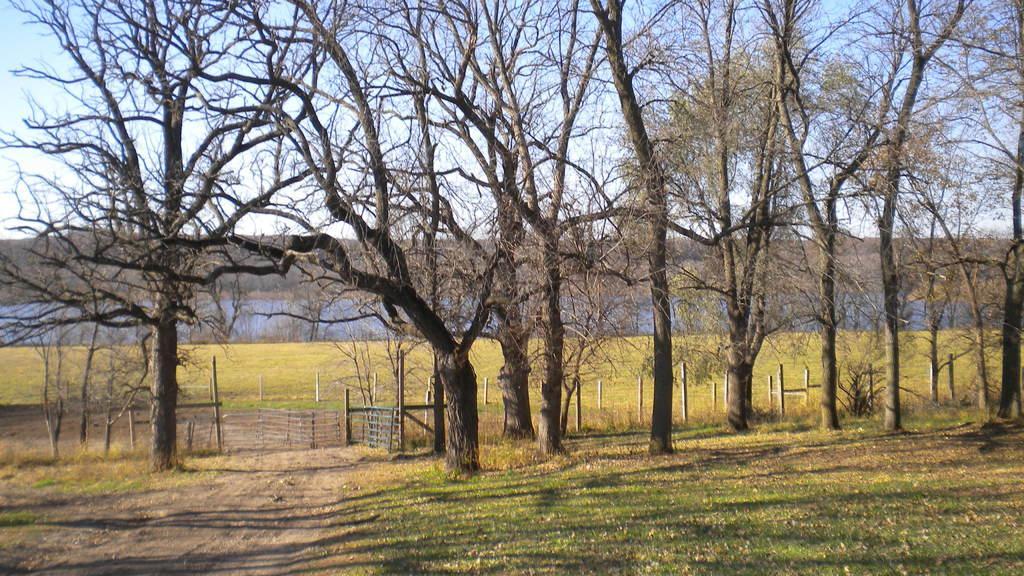Could you give a brief overview of what you see in this image? There are few dried trees and there is a fence beside it and the ground is greenery. 